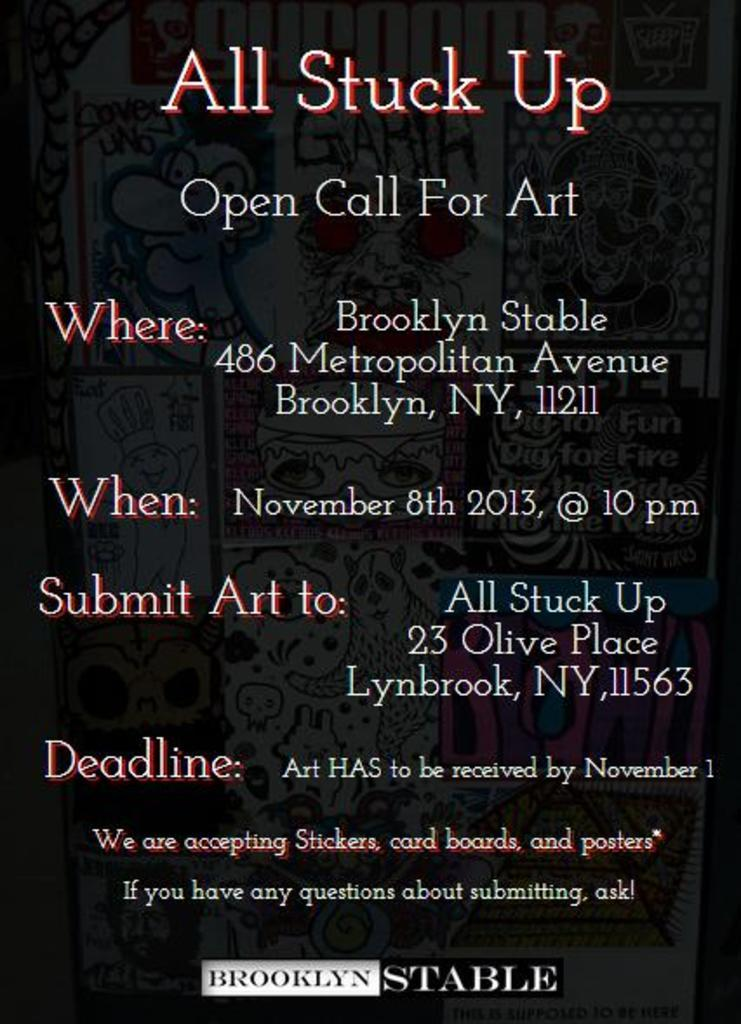Provide a one-sentence caption for the provided image. A flyer for an event call All Stuck Up taking place on November 8th in Brooklyn New York. 